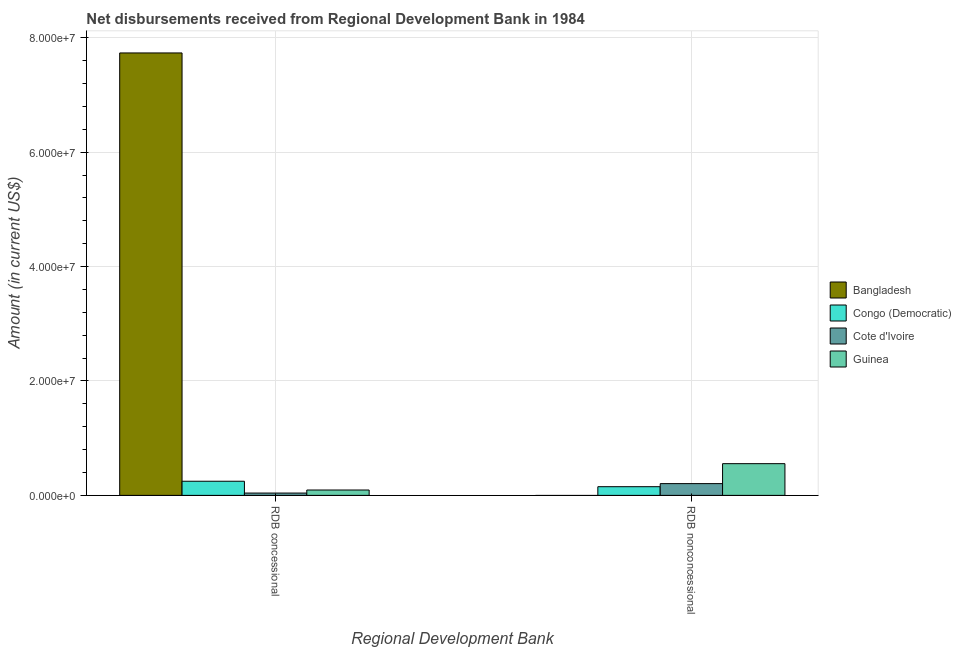How many different coloured bars are there?
Your answer should be very brief. 4. Are the number of bars per tick equal to the number of legend labels?
Your answer should be compact. No. How many bars are there on the 2nd tick from the left?
Provide a short and direct response. 3. How many bars are there on the 1st tick from the right?
Make the answer very short. 3. What is the label of the 1st group of bars from the left?
Provide a succinct answer. RDB concessional. What is the net concessional disbursements from rdb in Congo (Democratic)?
Provide a short and direct response. 2.47e+06. Across all countries, what is the maximum net non concessional disbursements from rdb?
Your answer should be very brief. 5.55e+06. In which country was the net non concessional disbursements from rdb maximum?
Ensure brevity in your answer.  Guinea. What is the total net non concessional disbursements from rdb in the graph?
Provide a short and direct response. 9.12e+06. What is the difference between the net concessional disbursements from rdb in Guinea and that in Cote d'Ivoire?
Make the answer very short. 5.33e+05. What is the difference between the net non concessional disbursements from rdb in Cote d'Ivoire and the net concessional disbursements from rdb in Guinea?
Your answer should be compact. 1.12e+06. What is the average net non concessional disbursements from rdb per country?
Give a very brief answer. 2.28e+06. What is the difference between the net non concessional disbursements from rdb and net concessional disbursements from rdb in Guinea?
Give a very brief answer. 4.61e+06. In how many countries, is the net concessional disbursements from rdb greater than 60000000 US$?
Make the answer very short. 1. What is the ratio of the net non concessional disbursements from rdb in Congo (Democratic) to that in Guinea?
Your answer should be very brief. 0.27. In how many countries, is the net concessional disbursements from rdb greater than the average net concessional disbursements from rdb taken over all countries?
Provide a short and direct response. 1. How many bars are there?
Your answer should be very brief. 7. How many countries are there in the graph?
Your answer should be compact. 4. Does the graph contain grids?
Your answer should be compact. Yes. Where does the legend appear in the graph?
Offer a very short reply. Center right. What is the title of the graph?
Ensure brevity in your answer.  Net disbursements received from Regional Development Bank in 1984. What is the label or title of the X-axis?
Give a very brief answer. Regional Development Bank. What is the Amount (in current US$) in Bangladesh in RDB concessional?
Provide a succinct answer. 7.73e+07. What is the Amount (in current US$) of Congo (Democratic) in RDB concessional?
Keep it short and to the point. 2.47e+06. What is the Amount (in current US$) of Cote d'Ivoire in RDB concessional?
Offer a very short reply. 4.07e+05. What is the Amount (in current US$) of Guinea in RDB concessional?
Offer a very short reply. 9.40e+05. What is the Amount (in current US$) in Bangladesh in RDB nonconcessional?
Your response must be concise. 0. What is the Amount (in current US$) in Congo (Democratic) in RDB nonconcessional?
Your answer should be very brief. 1.52e+06. What is the Amount (in current US$) of Cote d'Ivoire in RDB nonconcessional?
Your answer should be compact. 2.06e+06. What is the Amount (in current US$) in Guinea in RDB nonconcessional?
Provide a succinct answer. 5.55e+06. Across all Regional Development Bank, what is the maximum Amount (in current US$) of Bangladesh?
Ensure brevity in your answer.  7.73e+07. Across all Regional Development Bank, what is the maximum Amount (in current US$) of Congo (Democratic)?
Make the answer very short. 2.47e+06. Across all Regional Development Bank, what is the maximum Amount (in current US$) of Cote d'Ivoire?
Your answer should be compact. 2.06e+06. Across all Regional Development Bank, what is the maximum Amount (in current US$) of Guinea?
Your response must be concise. 5.55e+06. Across all Regional Development Bank, what is the minimum Amount (in current US$) in Congo (Democratic)?
Provide a short and direct response. 1.52e+06. Across all Regional Development Bank, what is the minimum Amount (in current US$) of Cote d'Ivoire?
Your answer should be very brief. 4.07e+05. Across all Regional Development Bank, what is the minimum Amount (in current US$) of Guinea?
Provide a short and direct response. 9.40e+05. What is the total Amount (in current US$) of Bangladesh in the graph?
Give a very brief answer. 7.73e+07. What is the total Amount (in current US$) of Congo (Democratic) in the graph?
Provide a short and direct response. 3.99e+06. What is the total Amount (in current US$) in Cote d'Ivoire in the graph?
Provide a succinct answer. 2.46e+06. What is the total Amount (in current US$) in Guinea in the graph?
Provide a short and direct response. 6.49e+06. What is the difference between the Amount (in current US$) in Congo (Democratic) in RDB concessional and that in RDB nonconcessional?
Your response must be concise. 9.54e+05. What is the difference between the Amount (in current US$) in Cote d'Ivoire in RDB concessional and that in RDB nonconcessional?
Keep it short and to the point. -1.65e+06. What is the difference between the Amount (in current US$) in Guinea in RDB concessional and that in RDB nonconcessional?
Make the answer very short. -4.61e+06. What is the difference between the Amount (in current US$) in Bangladesh in RDB concessional and the Amount (in current US$) in Congo (Democratic) in RDB nonconcessional?
Give a very brief answer. 7.58e+07. What is the difference between the Amount (in current US$) of Bangladesh in RDB concessional and the Amount (in current US$) of Cote d'Ivoire in RDB nonconcessional?
Make the answer very short. 7.53e+07. What is the difference between the Amount (in current US$) in Bangladesh in RDB concessional and the Amount (in current US$) in Guinea in RDB nonconcessional?
Offer a terse response. 7.18e+07. What is the difference between the Amount (in current US$) of Congo (Democratic) in RDB concessional and the Amount (in current US$) of Cote d'Ivoire in RDB nonconcessional?
Give a very brief answer. 4.15e+05. What is the difference between the Amount (in current US$) of Congo (Democratic) in RDB concessional and the Amount (in current US$) of Guinea in RDB nonconcessional?
Offer a terse response. -3.07e+06. What is the difference between the Amount (in current US$) of Cote d'Ivoire in RDB concessional and the Amount (in current US$) of Guinea in RDB nonconcessional?
Offer a terse response. -5.14e+06. What is the average Amount (in current US$) in Bangladesh per Regional Development Bank?
Provide a succinct answer. 3.87e+07. What is the average Amount (in current US$) of Congo (Democratic) per Regional Development Bank?
Offer a terse response. 2.00e+06. What is the average Amount (in current US$) in Cote d'Ivoire per Regional Development Bank?
Your answer should be compact. 1.23e+06. What is the average Amount (in current US$) of Guinea per Regional Development Bank?
Your answer should be very brief. 3.24e+06. What is the difference between the Amount (in current US$) of Bangladesh and Amount (in current US$) of Congo (Democratic) in RDB concessional?
Ensure brevity in your answer.  7.49e+07. What is the difference between the Amount (in current US$) in Bangladesh and Amount (in current US$) in Cote d'Ivoire in RDB concessional?
Provide a succinct answer. 7.69e+07. What is the difference between the Amount (in current US$) of Bangladesh and Amount (in current US$) of Guinea in RDB concessional?
Your answer should be compact. 7.64e+07. What is the difference between the Amount (in current US$) of Congo (Democratic) and Amount (in current US$) of Cote d'Ivoire in RDB concessional?
Make the answer very short. 2.07e+06. What is the difference between the Amount (in current US$) of Congo (Democratic) and Amount (in current US$) of Guinea in RDB concessional?
Your response must be concise. 1.53e+06. What is the difference between the Amount (in current US$) of Cote d'Ivoire and Amount (in current US$) of Guinea in RDB concessional?
Your answer should be compact. -5.33e+05. What is the difference between the Amount (in current US$) of Congo (Democratic) and Amount (in current US$) of Cote d'Ivoire in RDB nonconcessional?
Make the answer very short. -5.39e+05. What is the difference between the Amount (in current US$) in Congo (Democratic) and Amount (in current US$) in Guinea in RDB nonconcessional?
Ensure brevity in your answer.  -4.03e+06. What is the difference between the Amount (in current US$) of Cote d'Ivoire and Amount (in current US$) of Guinea in RDB nonconcessional?
Provide a short and direct response. -3.49e+06. What is the ratio of the Amount (in current US$) of Congo (Democratic) in RDB concessional to that in RDB nonconcessional?
Give a very brief answer. 1.63. What is the ratio of the Amount (in current US$) in Cote d'Ivoire in RDB concessional to that in RDB nonconcessional?
Your answer should be very brief. 0.2. What is the ratio of the Amount (in current US$) in Guinea in RDB concessional to that in RDB nonconcessional?
Your response must be concise. 0.17. What is the difference between the highest and the second highest Amount (in current US$) in Congo (Democratic)?
Keep it short and to the point. 9.54e+05. What is the difference between the highest and the second highest Amount (in current US$) of Cote d'Ivoire?
Give a very brief answer. 1.65e+06. What is the difference between the highest and the second highest Amount (in current US$) of Guinea?
Give a very brief answer. 4.61e+06. What is the difference between the highest and the lowest Amount (in current US$) in Bangladesh?
Give a very brief answer. 7.73e+07. What is the difference between the highest and the lowest Amount (in current US$) in Congo (Democratic)?
Provide a short and direct response. 9.54e+05. What is the difference between the highest and the lowest Amount (in current US$) of Cote d'Ivoire?
Offer a terse response. 1.65e+06. What is the difference between the highest and the lowest Amount (in current US$) in Guinea?
Your response must be concise. 4.61e+06. 